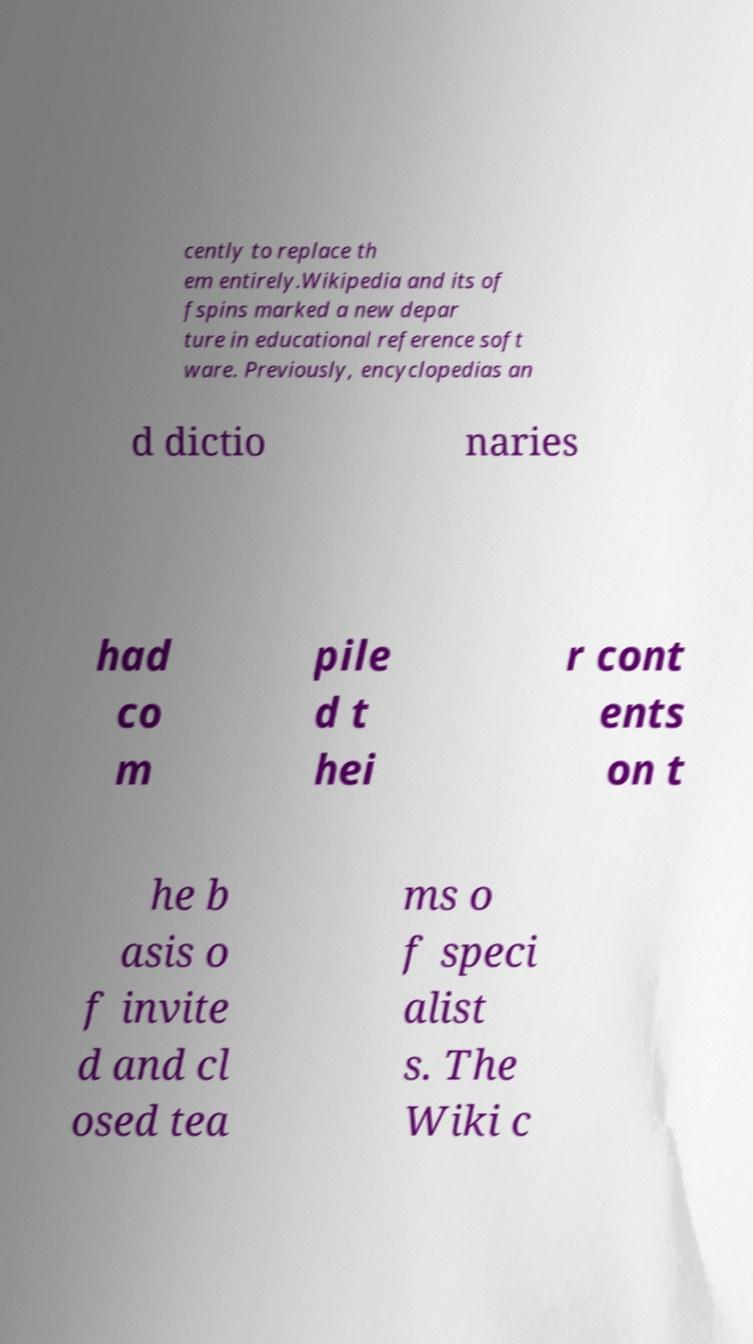There's text embedded in this image that I need extracted. Can you transcribe it verbatim? cently to replace th em entirely.Wikipedia and its of fspins marked a new depar ture in educational reference soft ware. Previously, encyclopedias an d dictio naries had co m pile d t hei r cont ents on t he b asis o f invite d and cl osed tea ms o f speci alist s. The Wiki c 